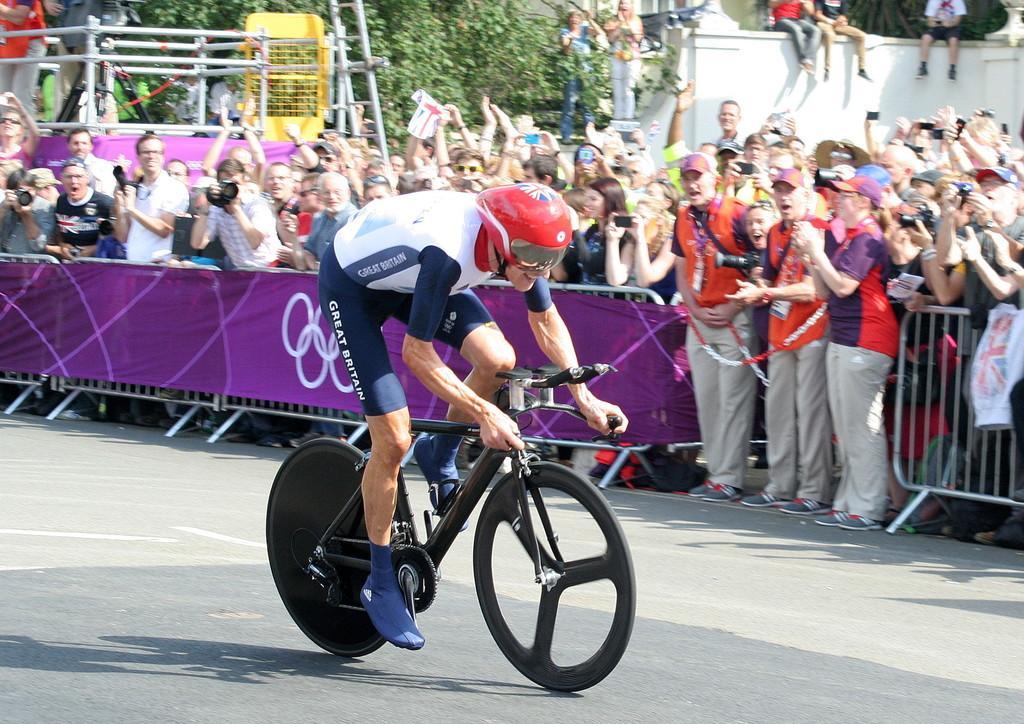Please provide a concise description of this image. In this picture we can see a person riding a bicycle, in the background we can see some of the barricades here and group of people cheering for him, in the background we can see a wall and trees here. 